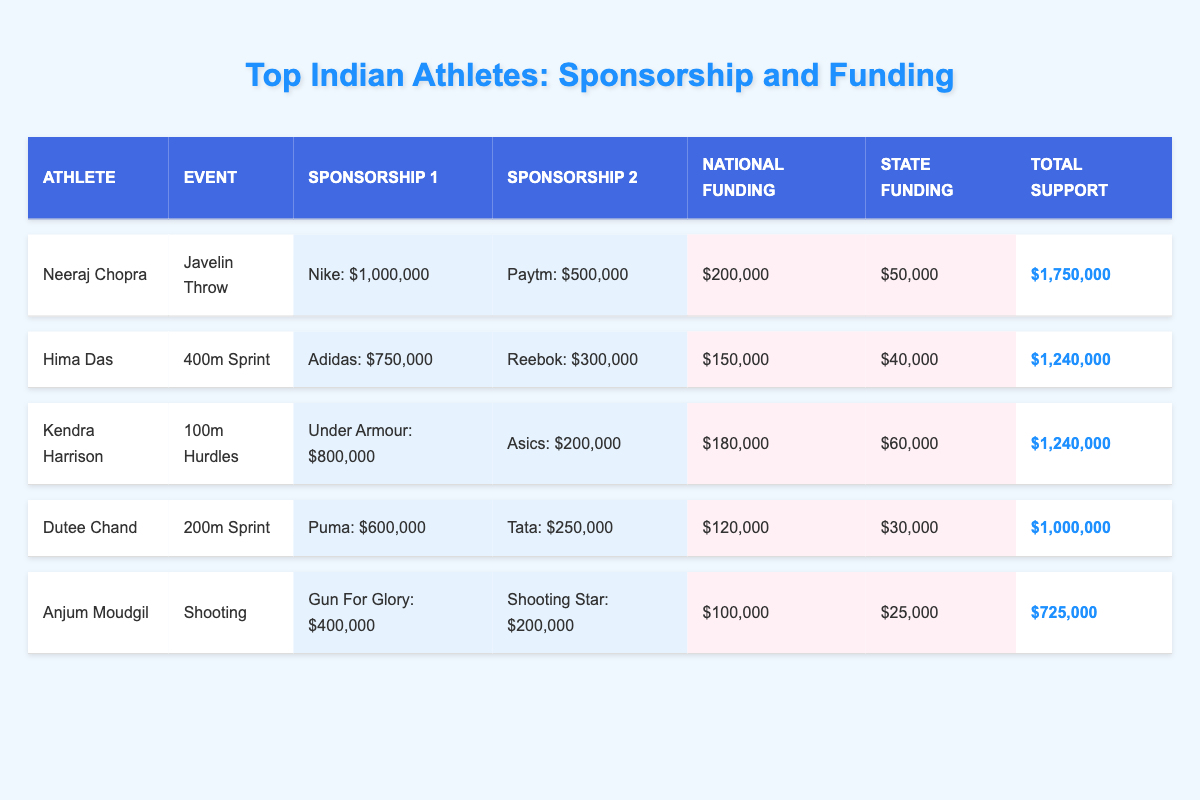What is the total sponsorship amount received by Neeraj Chopra? Neeraj Chopra has two sponsorships: Nike providing $1,000,000 and Paytm providing $500,000. Adding these together gives $1,000,000 + $500,000 = $1,500,000.
Answer: $1,500,000 Which athlete has the highest total financial support? The total support for each athlete is calculated as follows: Neeraj Chopra: $1,750,000, Hima Das: $1,240,000, Kendra Harrison: $1,240,000, Dutee Chand: $1,000,000, Anjum Moudgil: $725,000. Neeraj Chopra has the highest total support of $1,750,000.
Answer: Neeraj Chopra Did Anjum Moudgil receive more national or state funding? Anjum Moudgil received $100,000 in national funding and $25,000 in state funding. Since $100,000 is greater than $25,000, she received more national funding.
Answer: Yes, more national funding What is the combined sponsorship amount of Hima Das and Dutee Chand? Hima Das’s sponsorships total $750,000 (Adidas) + $300,000 (Reebok) = $1,050,000. Dutee Chand’s sponsorships total $600,000 (Puma) + $250,000 (Tata) = $850,000. Adding both sums gives $1,050,000 + $850,000 = $1,900,000.
Answer: $1,900,000 Is Kendra Harrison's total funding higher than Anjum Moudgil's? Kendra Harrison’s total support is $1,240,000 versus Anjum Moudgil's $725,000. Since $1,240,000 is greater than $725,000, Kendra Harrison's total funding is higher.
Answer: Yes, higher What percentage of Neeraj Chopra's total support comes from sponsorships? Neeraj Chopra's total support is $1,750,000. His sponsorships amount to $1,500,000. To find the percentage: ($1,500,000 / $1,750,000) * 100 = 85.71%.
Answer: 85.71% Which athlete received the least total funding? The total support amounts are compared: Neeraj Chopra: $1,750,000, Hima Das: $1,240,000, Kendra Harrison: $1,240,000, Dutee Chand: $1,000,000, Anjum Moudgil: $725,000. Anjum Moudgil has the least total funding with $725,000.
Answer: Anjum Moudgil What is the difference in total support between Dutee Chand and Hima Das? Dutee Chand's total support is $1,000,000 and Hima Das's total support is $1,240,000. The difference is $1,240,000 - $1,000,000 = $240,000.
Answer: $240,000 How much funding does Kendra Harrison receive from state sources? According to the table, Kendra Harrison's state funding amount is $60,000.
Answer: $60,000 Can you list all sponsorship brands that Anjum Moudgil has? Anjum Moudgil has two sponsorships: Gun For Glory and Shooting Star.
Answer: Gun For Glory, Shooting Star What is the total amount of funding from both national and state sources for Hima Das? Hima Das has national funding of $150,000 and state funding of $40,000. Adding these gives $150,000 + $40,000 = $190,000.
Answer: $190,000 